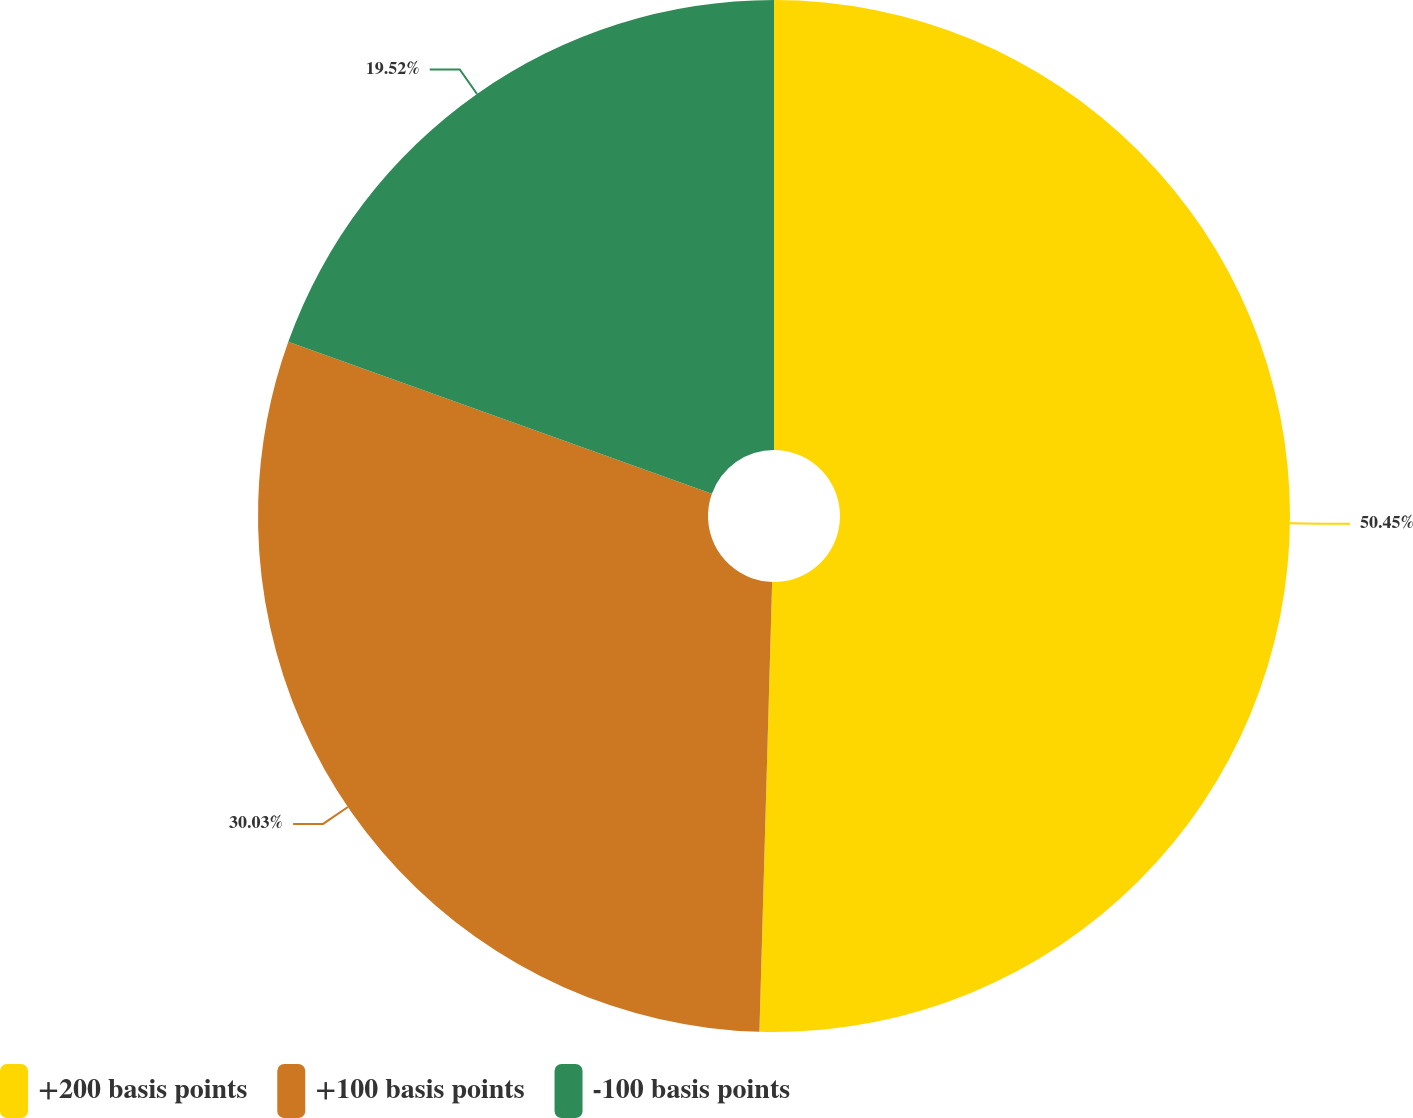Convert chart. <chart><loc_0><loc_0><loc_500><loc_500><pie_chart><fcel>+200 basis points<fcel>+100 basis points<fcel>-100 basis points<nl><fcel>50.45%<fcel>30.03%<fcel>19.52%<nl></chart> 